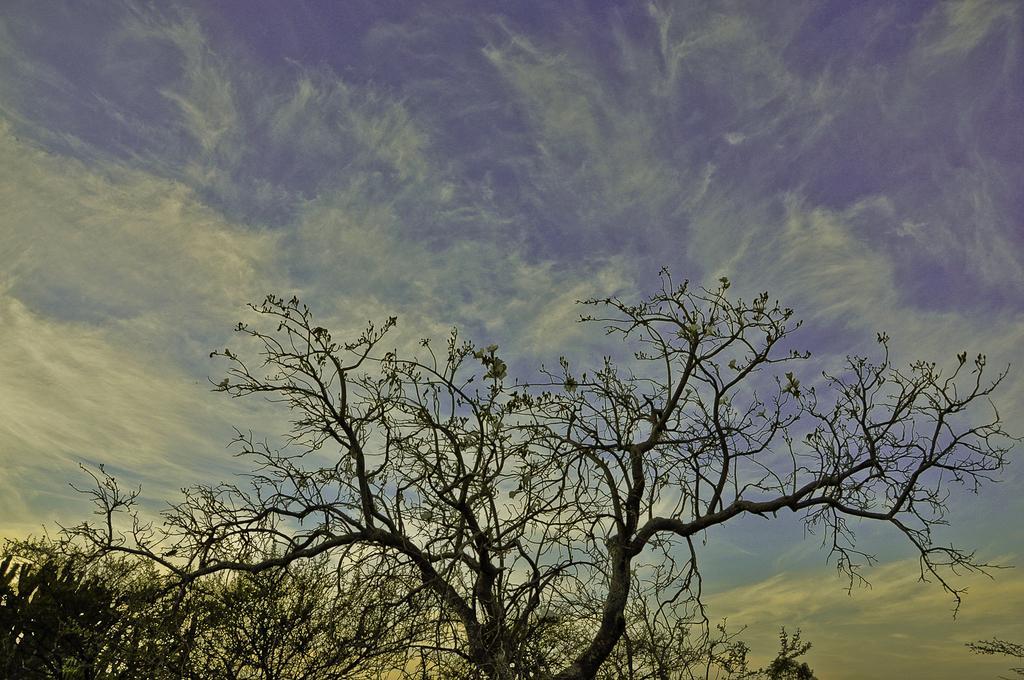Describe this image in one or two sentences. In this image, we can see some trees and the sky with clouds. 